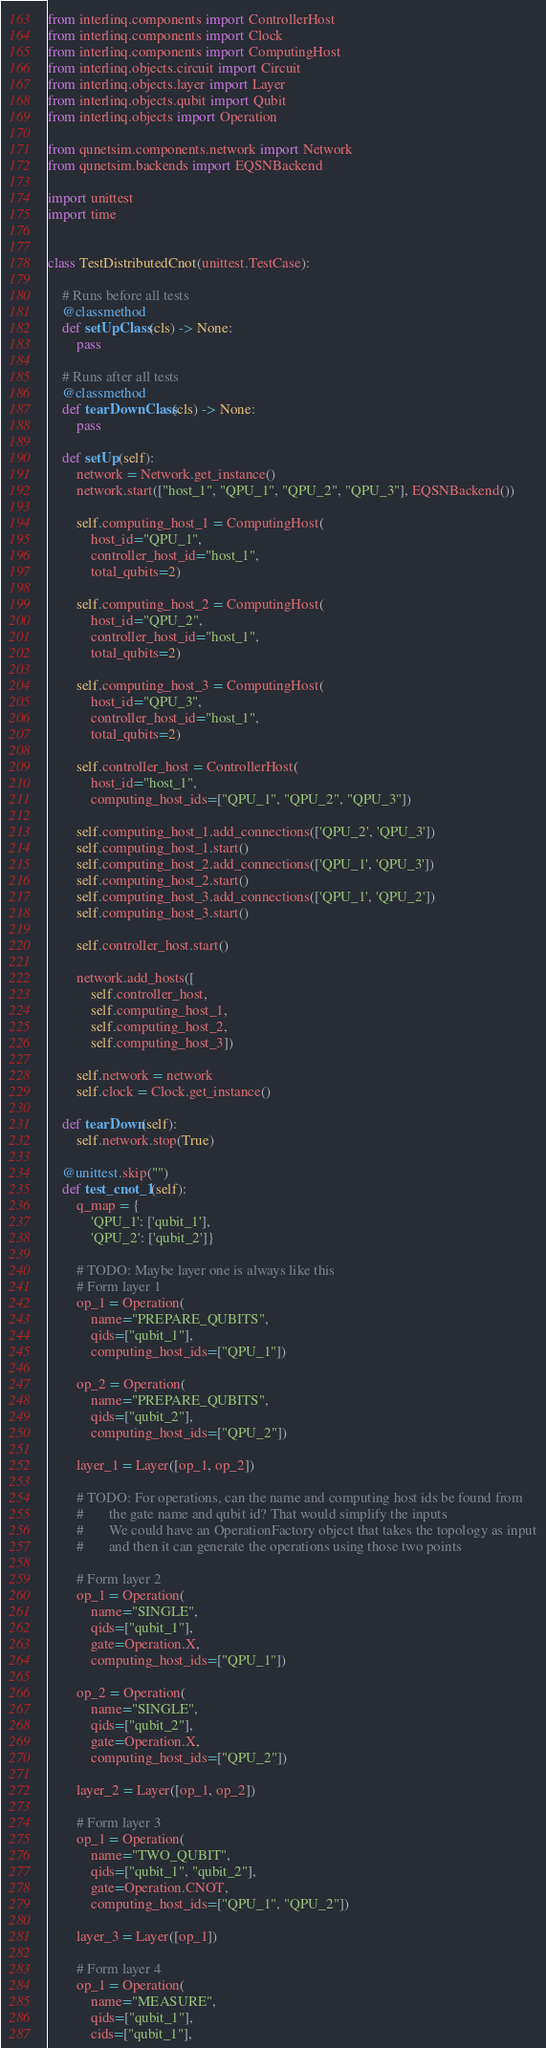Convert code to text. <code><loc_0><loc_0><loc_500><loc_500><_Python_>from interlinq.components import ControllerHost
from interlinq.components import Clock
from interlinq.components import ComputingHost
from interlinq.objects.circuit import Circuit
from interlinq.objects.layer import Layer
from interlinq.objects.qubit import Qubit
from interlinq.objects import Operation

from qunetsim.components.network import Network
from qunetsim.backends import EQSNBackend

import unittest
import time


class TestDistributedCnot(unittest.TestCase):

    # Runs before all tests
    @classmethod
    def setUpClass(cls) -> None:
        pass

    # Runs after all tests
    @classmethod
    def tearDownClass(cls) -> None:
        pass

    def setUp(self):
        network = Network.get_instance()
        network.start(["host_1", "QPU_1", "QPU_2", "QPU_3"], EQSNBackend())

        self.computing_host_1 = ComputingHost(
            host_id="QPU_1",
            controller_host_id="host_1",
            total_qubits=2)

        self.computing_host_2 = ComputingHost(
            host_id="QPU_2",
            controller_host_id="host_1",
            total_qubits=2)

        self.computing_host_3 = ComputingHost(
            host_id="QPU_3",
            controller_host_id="host_1",
            total_qubits=2)

        self.controller_host = ControllerHost(
            host_id="host_1",
            computing_host_ids=["QPU_1", "QPU_2", "QPU_3"])

        self.computing_host_1.add_connections(['QPU_2', 'QPU_3'])
        self.computing_host_1.start()
        self.computing_host_2.add_connections(['QPU_1', 'QPU_3'])
        self.computing_host_2.start()
        self.computing_host_3.add_connections(['QPU_1', 'QPU_2'])
        self.computing_host_3.start()

        self.controller_host.start()

        network.add_hosts([
            self.controller_host,
            self.computing_host_1,
            self.computing_host_2,
            self.computing_host_3])

        self.network = network
        self.clock = Clock.get_instance()

    def tearDown(self):
        self.network.stop(True)

    @unittest.skip("")
    def test_cnot_1(self):
        q_map = {
            'QPU_1': ['qubit_1'],
            'QPU_2': ['qubit_2']}

        # TODO: Maybe layer one is always like this
        # Form layer 1
        op_1 = Operation(
            name="PREPARE_QUBITS",
            qids=["qubit_1"],
            computing_host_ids=["QPU_1"])

        op_2 = Operation(
            name="PREPARE_QUBITS",
            qids=["qubit_2"],
            computing_host_ids=["QPU_2"])

        layer_1 = Layer([op_1, op_2])

        # TODO: For operations, can the name and computing host ids be found from
        #       the gate name and qubit id? That would simplify the inputs
        #       We could have an OperationFactory object that takes the topology as input
        #       and then it can generate the operations using those two points

        # Form layer 2
        op_1 = Operation(
            name="SINGLE",
            qids=["qubit_1"],
            gate=Operation.X,
            computing_host_ids=["QPU_1"])

        op_2 = Operation(
            name="SINGLE",
            qids=["qubit_2"],
            gate=Operation.X,
            computing_host_ids=["QPU_2"])

        layer_2 = Layer([op_1, op_2])

        # Form layer 3
        op_1 = Operation(
            name="TWO_QUBIT",
            qids=["qubit_1", "qubit_2"],
            gate=Operation.CNOT,
            computing_host_ids=["QPU_1", "QPU_2"])

        layer_3 = Layer([op_1])

        # Form layer 4
        op_1 = Operation(
            name="MEASURE",
            qids=["qubit_1"],
            cids=["qubit_1"],</code> 